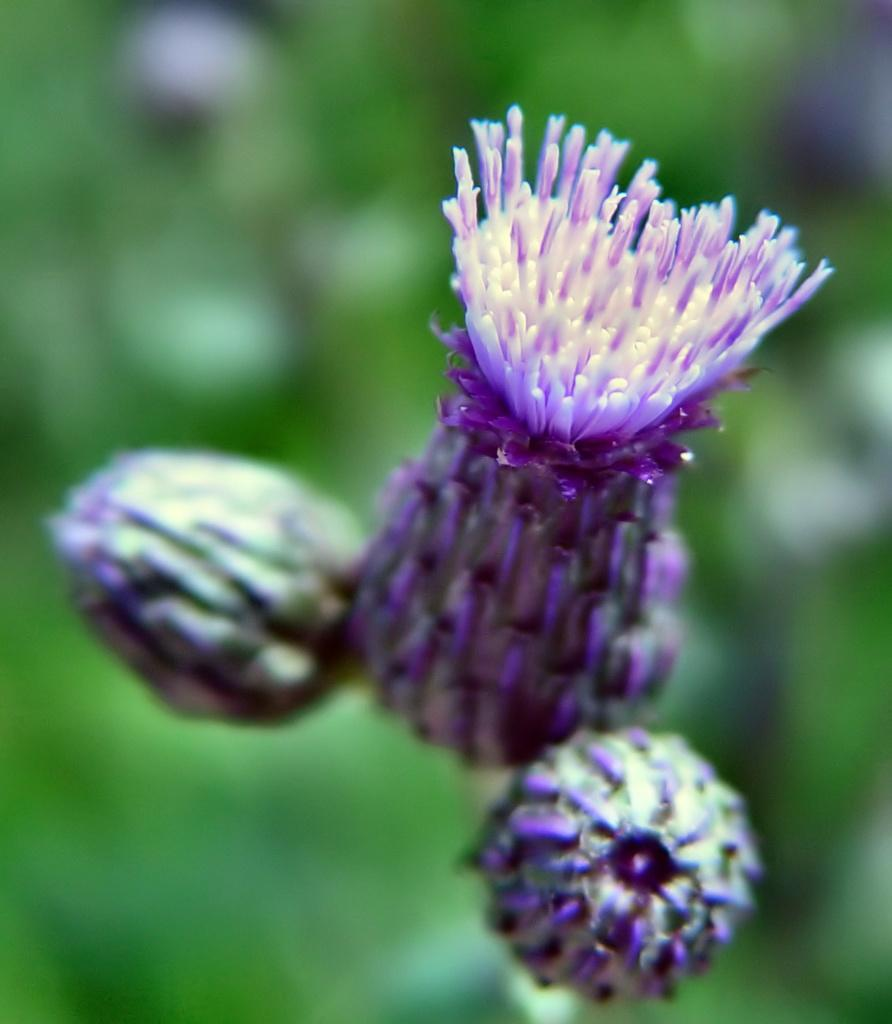What type of plant is featured in the image? There is a flower in the image. Are there any unopened parts of the flower visible? Yes, there are flower buds in the image. How would you describe the background of the image? The background of the image has a blurred view. What type of environment is depicted in the image? There is greenery visible in the image, suggesting a natural setting. How does the flower sneeze in the image? Flowers do not have the ability to sneeze, so this action cannot be observed in the image. 